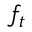<formula> <loc_0><loc_0><loc_500><loc_500>f _ { t }</formula> 